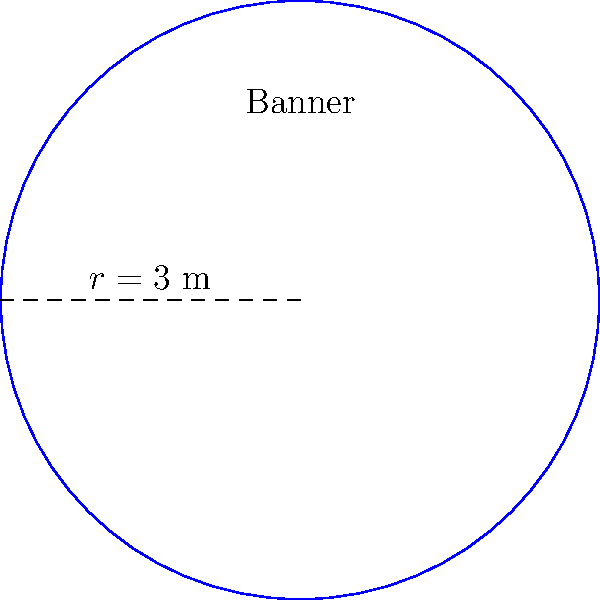You're designing a circular advertising banner for a local business to display at your amateur soccer games. The banner has a radius of 3 meters. What is the perimeter of the banner, rounded to the nearest centimeter? To find the perimeter of a circular banner, we need to calculate its circumference. The formula for the circumference of a circle is:

$$C = 2\pi r$$

Where:
$C$ is the circumference (perimeter)
$\pi$ is pi (approximately 3.14159)
$r$ is the radius

Given:
$r = 3$ meters

Step 1: Substitute the values into the formula
$$C = 2\pi(3)$$

Step 2: Calculate
$$C = 6\pi$$
$$C \approx 6 * 3.14159$$
$$C \approx 18.84954\text{ meters}$$

Step 3: Convert to centimeters
$$18.84954\text{ meters} * 100\text{ cm/m} = 1884.954\text{ cm}$$

Step 4: Round to the nearest centimeter
$$1884.954\text{ cm} \approx 1885\text{ cm}$$

Therefore, the perimeter of the circular banner is approximately 1885 cm.
Answer: 1885 cm 